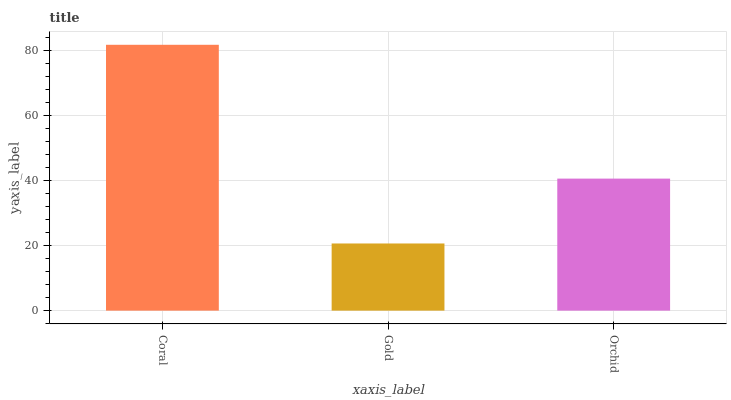Is Gold the minimum?
Answer yes or no. Yes. Is Coral the maximum?
Answer yes or no. Yes. Is Orchid the minimum?
Answer yes or no. No. Is Orchid the maximum?
Answer yes or no. No. Is Orchid greater than Gold?
Answer yes or no. Yes. Is Gold less than Orchid?
Answer yes or no. Yes. Is Gold greater than Orchid?
Answer yes or no. No. Is Orchid less than Gold?
Answer yes or no. No. Is Orchid the high median?
Answer yes or no. Yes. Is Orchid the low median?
Answer yes or no. Yes. Is Coral the high median?
Answer yes or no. No. Is Coral the low median?
Answer yes or no. No. 